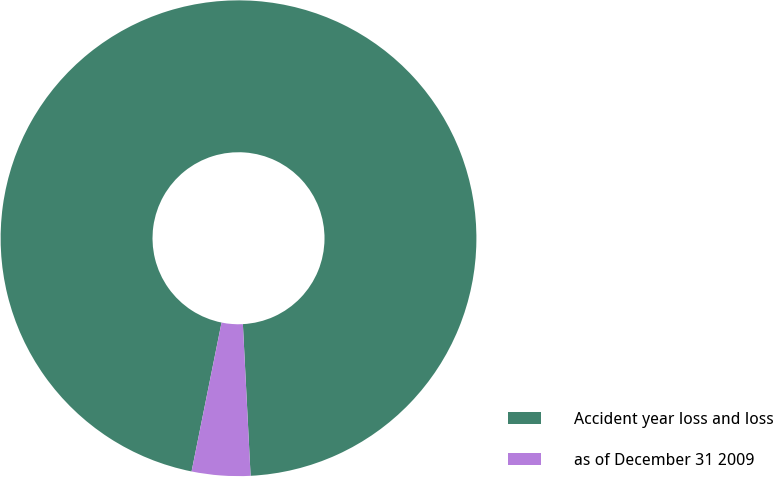Convert chart. <chart><loc_0><loc_0><loc_500><loc_500><pie_chart><fcel>Accident year loss and loss<fcel>as of December 31 2009<nl><fcel>96.03%<fcel>3.97%<nl></chart> 